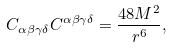Convert formula to latex. <formula><loc_0><loc_0><loc_500><loc_500>C _ { \alpha \beta \gamma \delta } C ^ { \alpha \beta \gamma \delta } = \frac { 4 8 M ^ { 2 } } { r ^ { 6 } } ,</formula> 